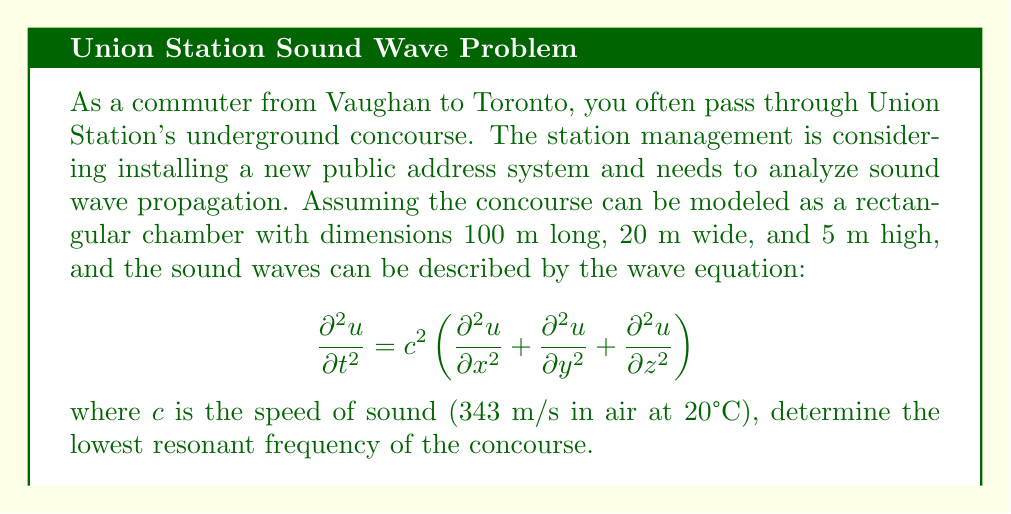Provide a solution to this math problem. To solve this problem, we need to follow these steps:

1) The general solution for the wave equation in a rectangular chamber with dimensions $L_x$, $L_y$, and $L_z$ is:

   $$u(x,y,z,t) = \sin(\frac{n_x\pi x}{L_x}) \sin(\frac{n_y\pi y}{L_y}) \sin(\frac{n_z\pi z}{L_z}) \cos(\omega t)$$

   where $n_x$, $n_y$, and $n_z$ are positive integers.

2) The corresponding frequencies are given by:

   $$f = \frac{c}{2} \sqrt{(\frac{n_x}{L_x})^2 + (\frac{n_y}{L_y})^2 + (\frac{n_z}{L_z})^2}$$

3) The lowest resonant frequency occurs when $n_x = 1$, $n_y = 0$, and $n_z = 0$. This corresponds to the longest dimension of the concourse.

4) Substituting the values:
   $c = 343$ m/s
   $L_x = 100$ m (longest dimension)

5) Calculate:

   $$f = \frac{343}{2} \sqrt{(\frac{1}{100})^2 + 0^2 + 0^2} = \frac{343}{200} = 1.715 \text{ Hz}$$

Therefore, the lowest resonant frequency of the concourse is approximately 1.715 Hz.
Answer: 1.715 Hz 